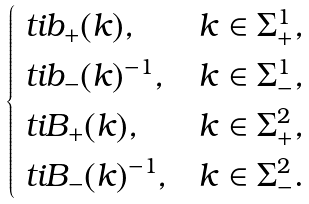<formula> <loc_0><loc_0><loc_500><loc_500>\begin{cases} \ t i { b } _ { + } ( k ) , & k \in \Sigma _ { + } ^ { 1 } , \\ \ t i { b } _ { - } ( k ) ^ { - 1 } , & k \in \Sigma _ { - } ^ { 1 } , \\ \ t i { B } _ { + } ( k ) , & k \in \Sigma _ { + } ^ { 2 } , \\ \ t i { B } _ { - } ( k ) ^ { - 1 } , & k \in \Sigma _ { - } ^ { 2 } . \end{cases}</formula> 